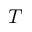<formula> <loc_0><loc_0><loc_500><loc_500>T</formula> 